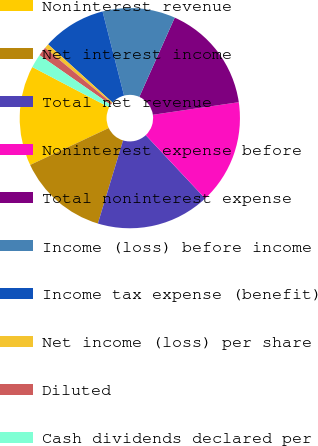Convert chart to OTSL. <chart><loc_0><loc_0><loc_500><loc_500><pie_chart><fcel>Noninterest revenue<fcel>Net interest income<fcel>Total net revenue<fcel>Noninterest expense before<fcel>Total noninterest expense<fcel>Income (loss) before income<fcel>Income tax expense (benefit)<fcel>Net income (loss) per share<fcel>Diluted<fcel>Cash dividends declared per<nl><fcel>14.67%<fcel>13.33%<fcel>16.67%<fcel>15.33%<fcel>16.0%<fcel>10.67%<fcel>9.33%<fcel>0.67%<fcel>1.33%<fcel>2.0%<nl></chart> 